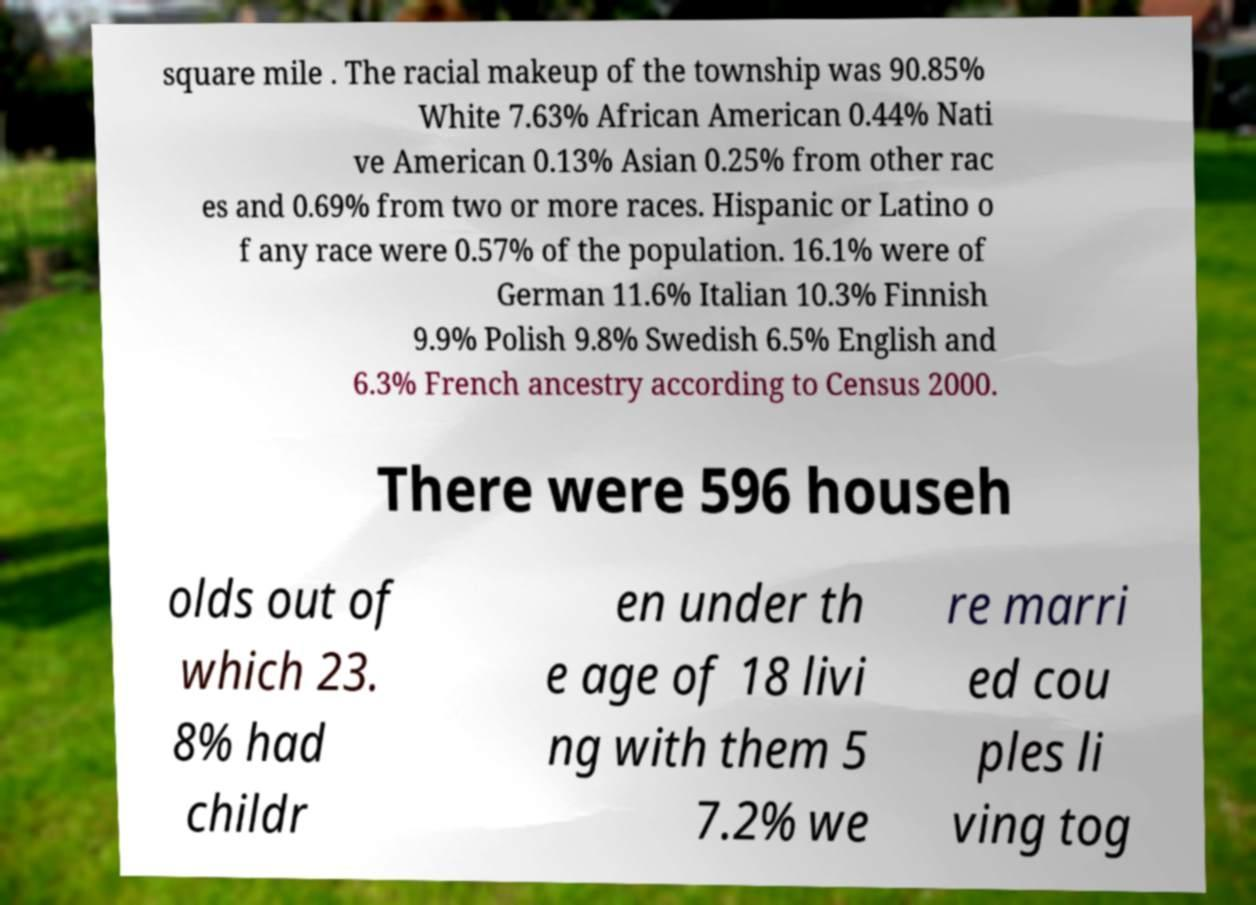Please identify and transcribe the text found in this image. square mile . The racial makeup of the township was 90.85% White 7.63% African American 0.44% Nati ve American 0.13% Asian 0.25% from other rac es and 0.69% from two or more races. Hispanic or Latino o f any race were 0.57% of the population. 16.1% were of German 11.6% Italian 10.3% Finnish 9.9% Polish 9.8% Swedish 6.5% English and 6.3% French ancestry according to Census 2000. There were 596 househ olds out of which 23. 8% had childr en under th e age of 18 livi ng with them 5 7.2% we re marri ed cou ples li ving tog 